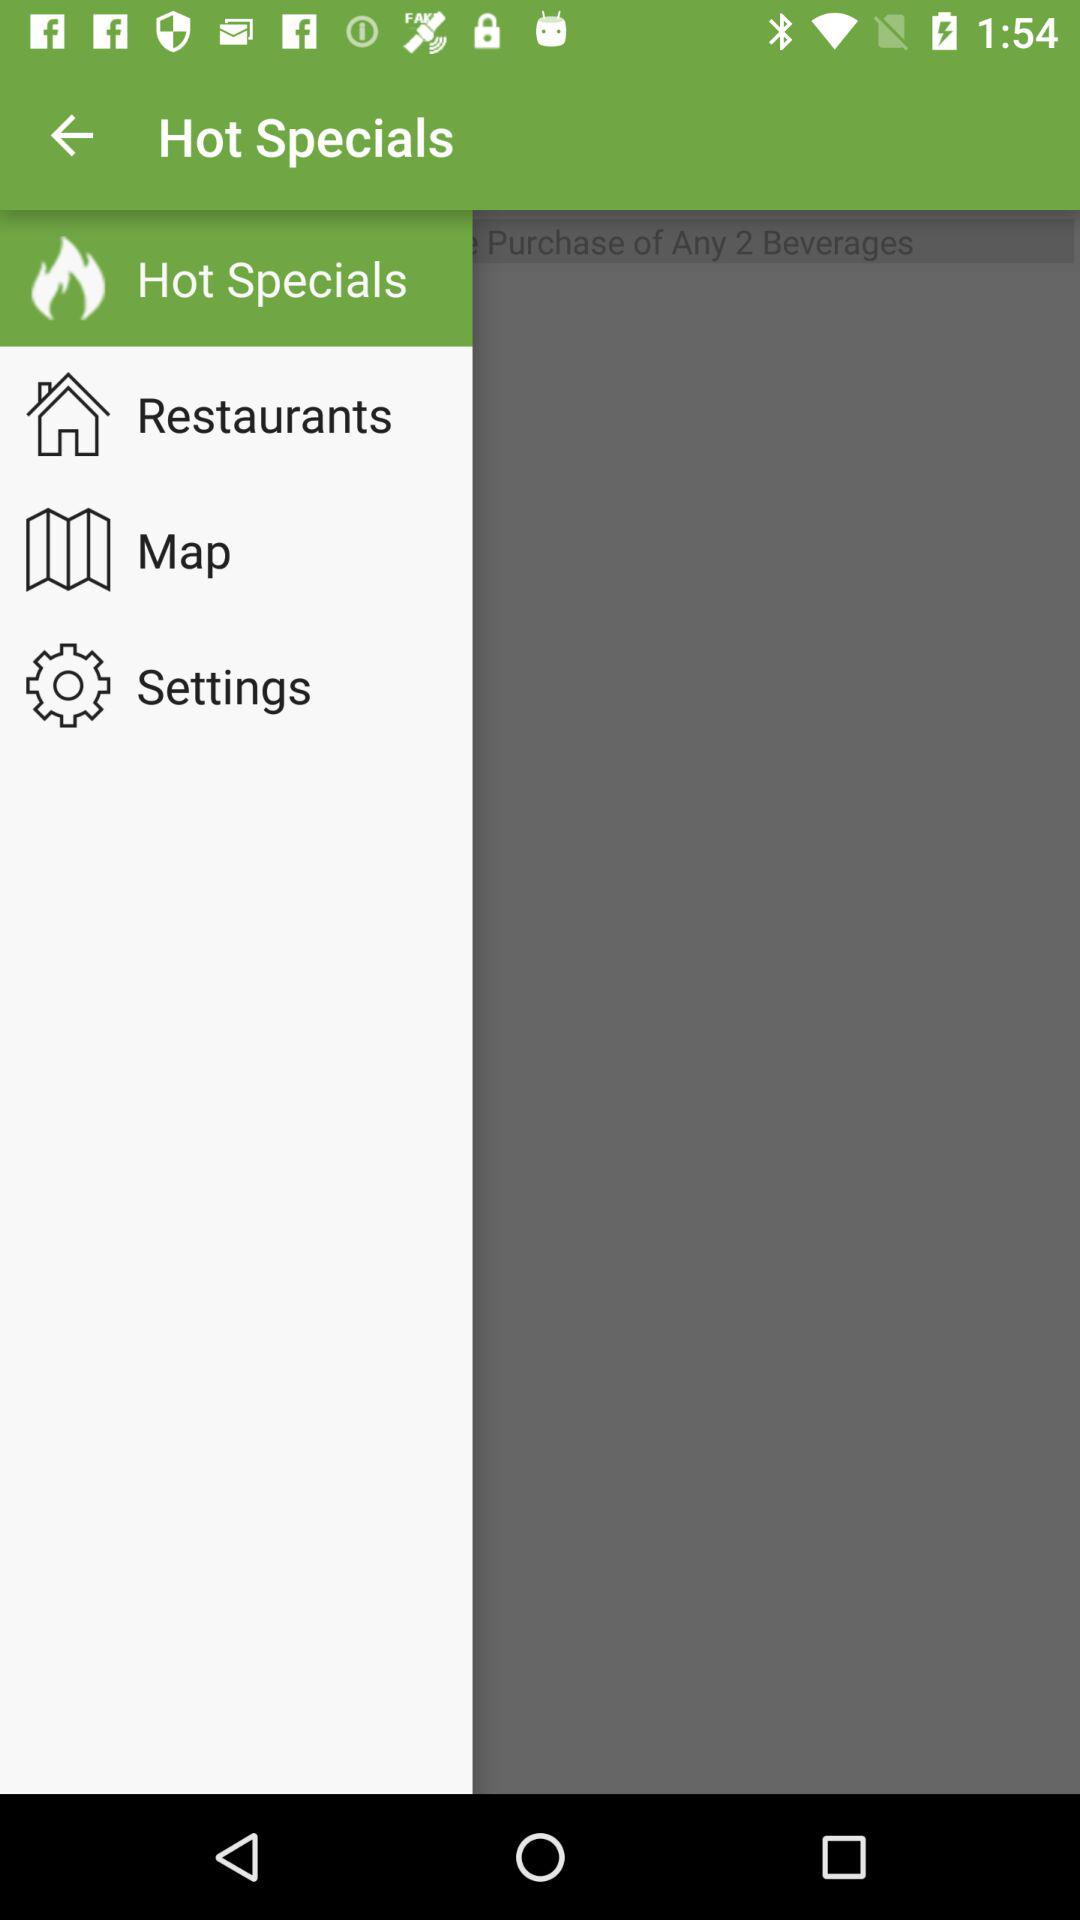Which item is currently selected? The currently selected item is "Hot Specials". 